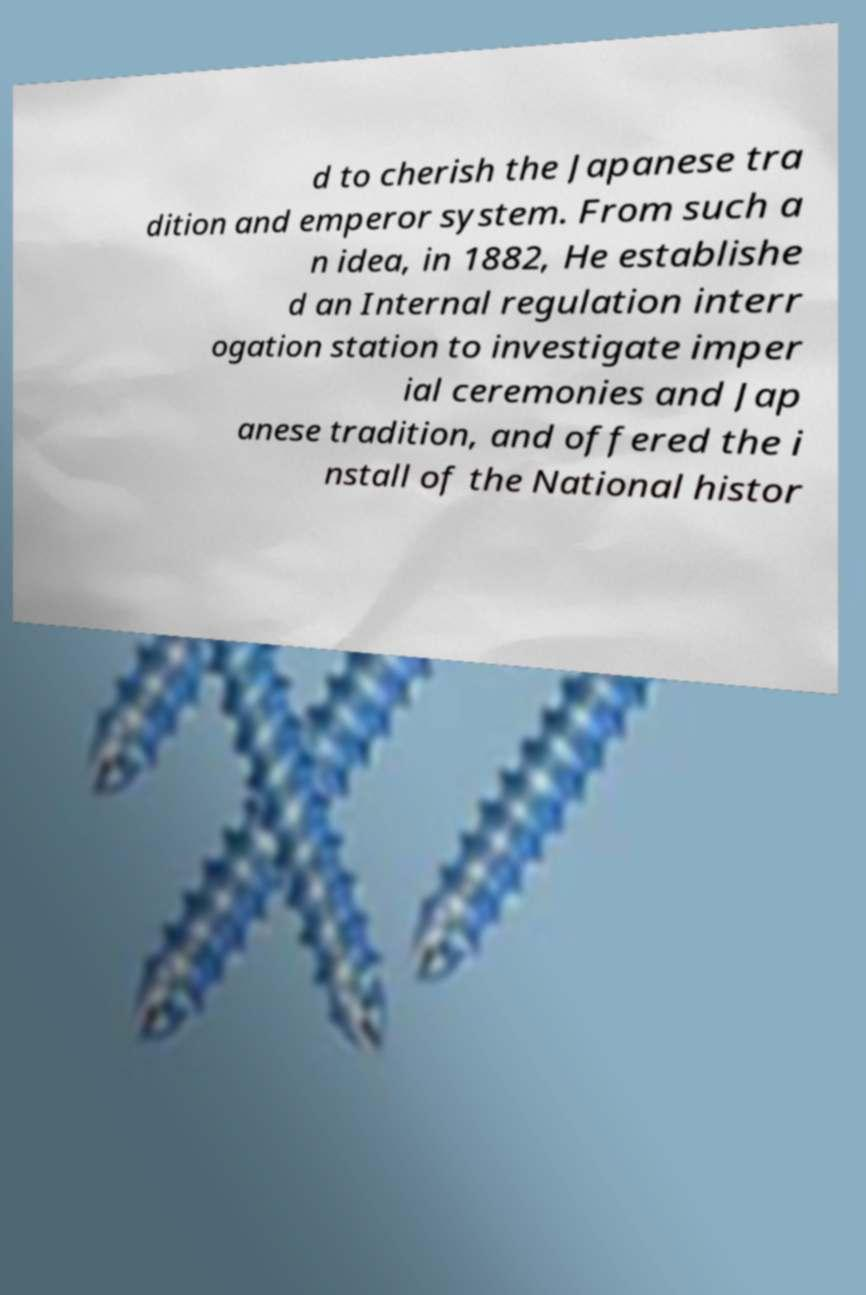Could you assist in decoding the text presented in this image and type it out clearly? d to cherish the Japanese tra dition and emperor system. From such a n idea, in 1882, He establishe d an Internal regulation interr ogation station to investigate imper ial ceremonies and Jap anese tradition, and offered the i nstall of the National histor 